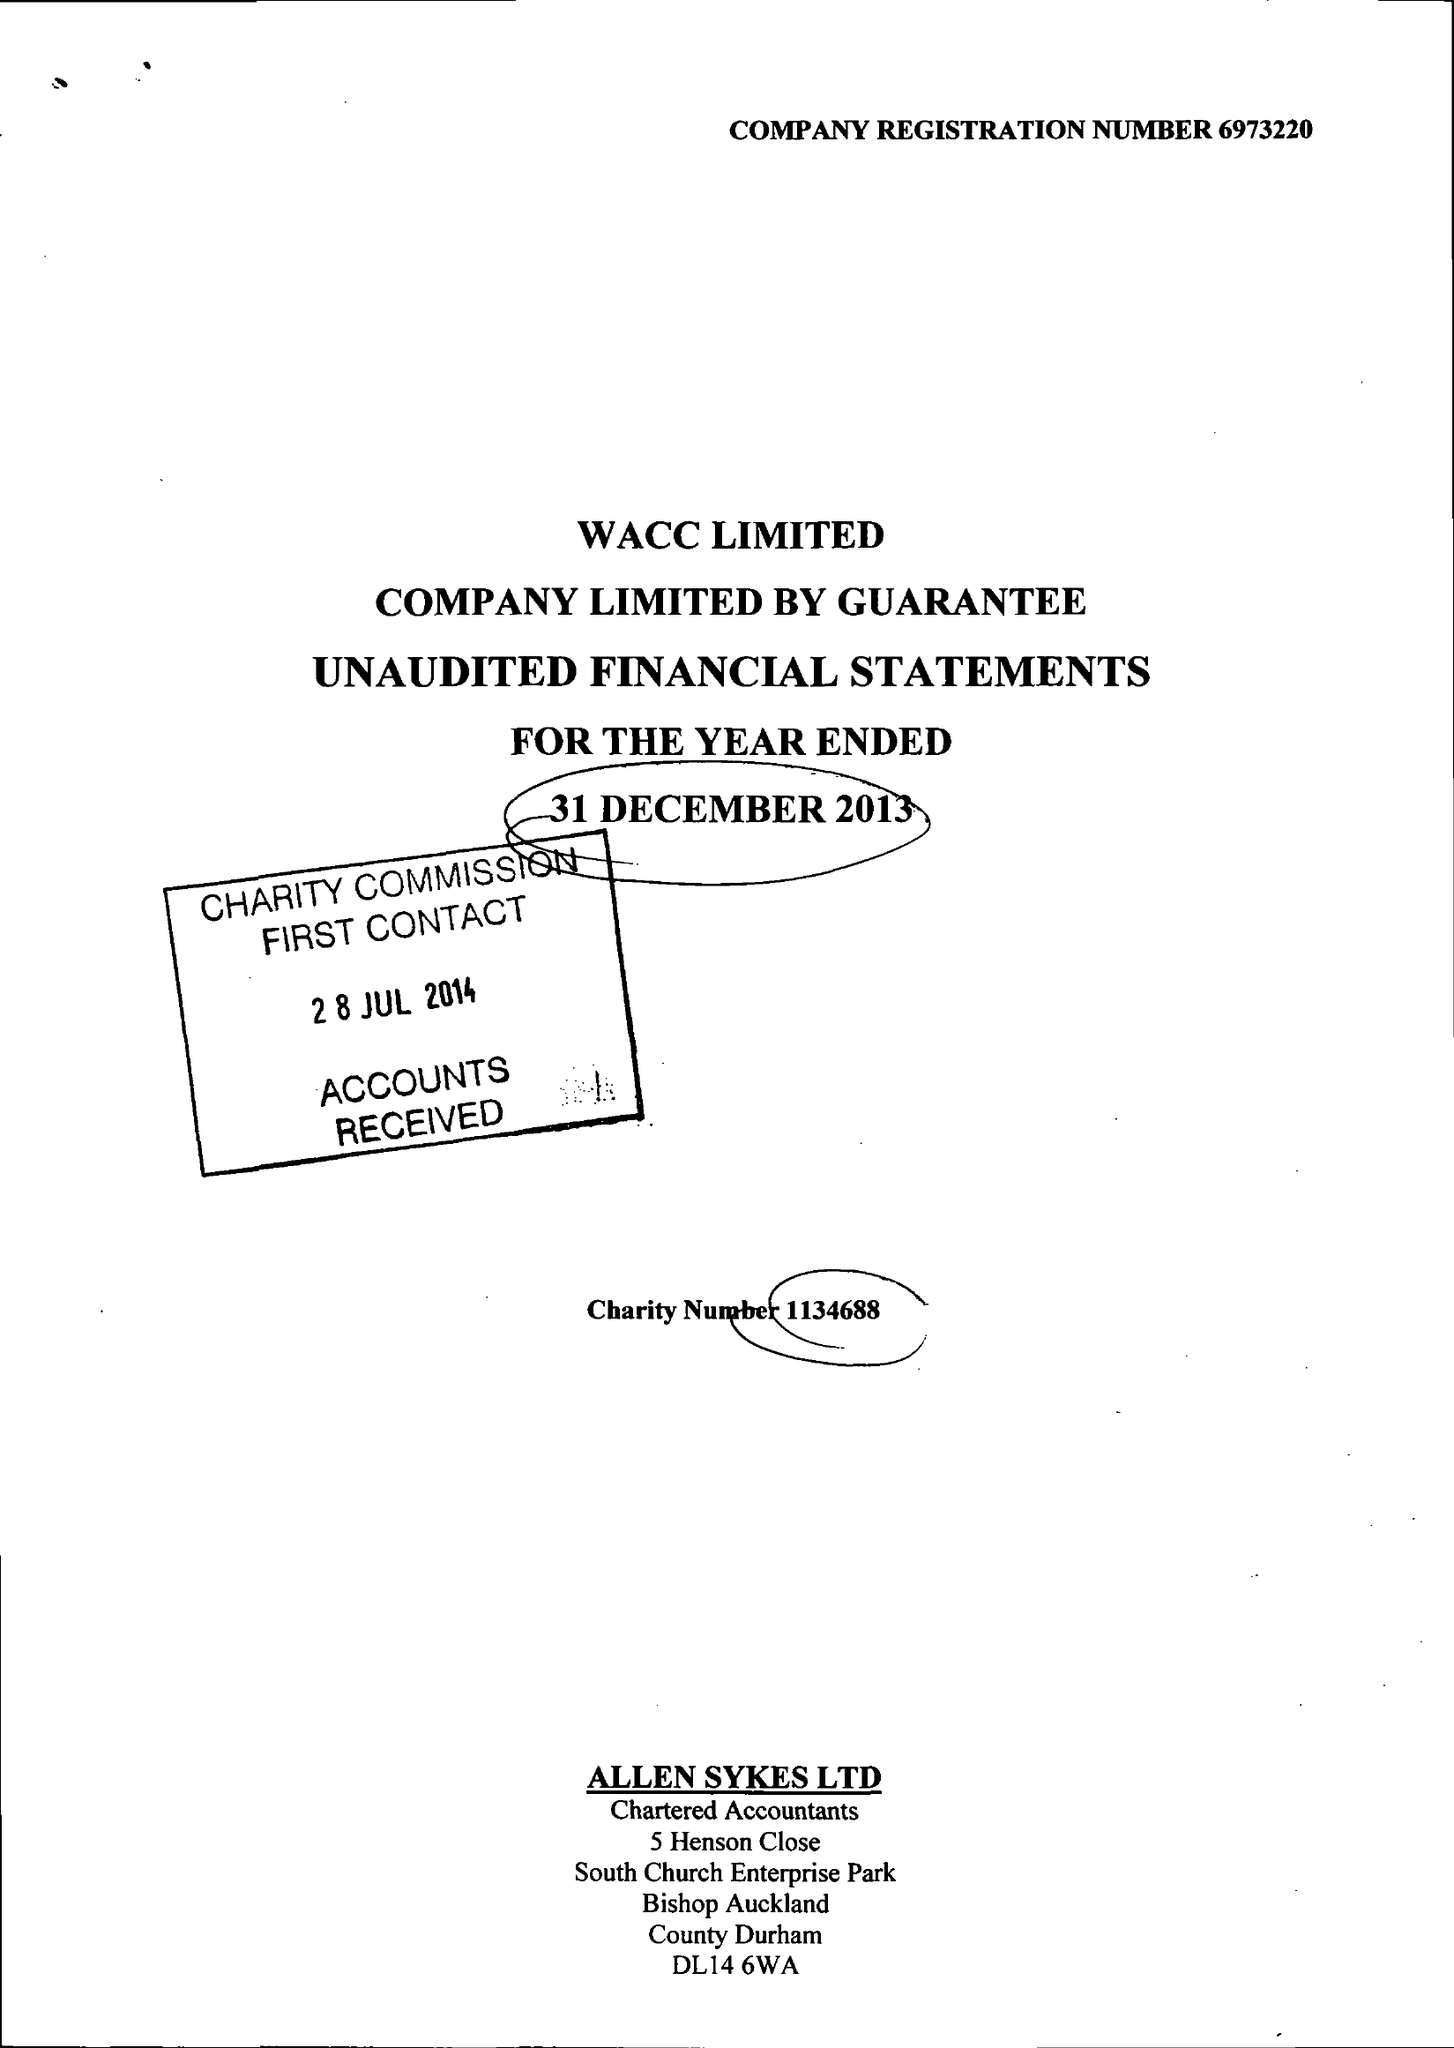What is the value for the charity_name?
Answer the question using a single word or phrase. West Auckland Community Church 